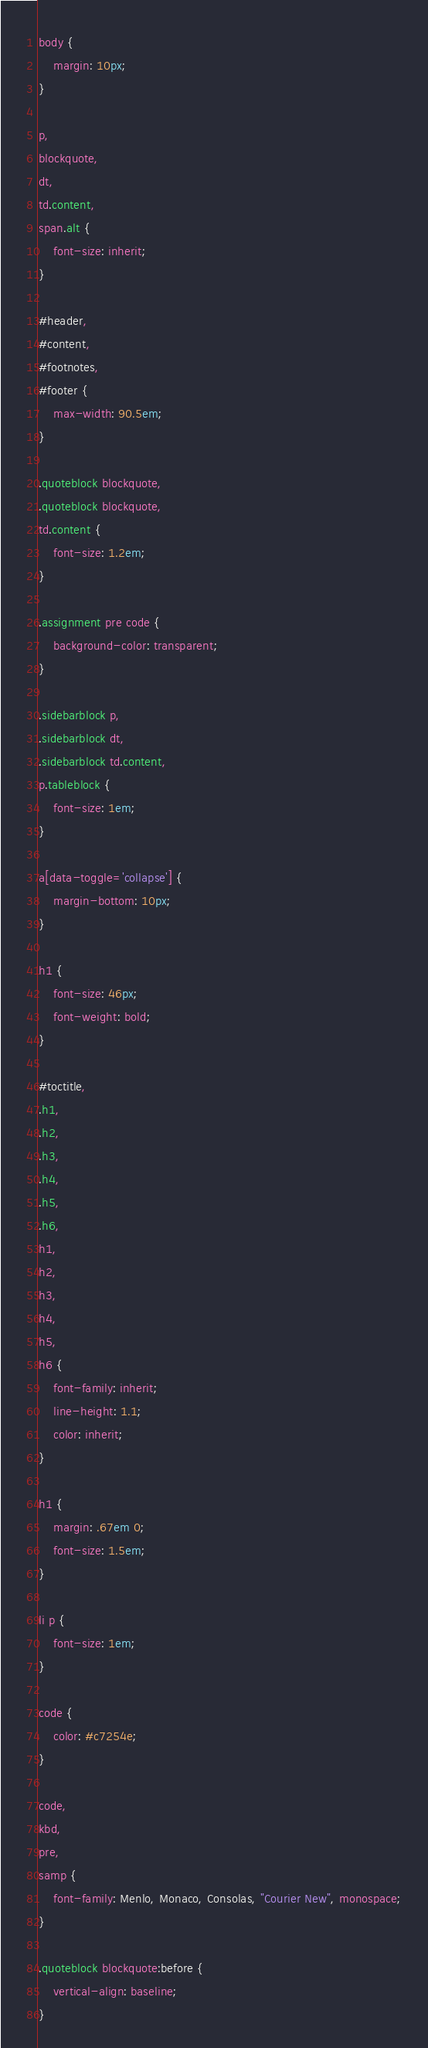<code> <loc_0><loc_0><loc_500><loc_500><_CSS_>body {
    margin: 10px;
}

p,
blockquote,
dt,
td.content,
span.alt {
    font-size: inherit;
}

#header,
#content,
#footnotes,
#footer {
    max-width: 90.5em;
}

.quoteblock blockquote,
.quoteblock blockquote,
td.content {
    font-size: 1.2em;
}

.assignment pre code {
    background-color: transparent;
}

.sidebarblock p,
.sidebarblock dt,
.sidebarblock td.content,
p.tableblock {
    font-size: 1em;
}

a[data-toggle='collapse'] {
    margin-bottom: 10px;
}

h1 {
    font-size: 46px;
    font-weight: bold;
}

#toctitle,
.h1,
.h2,
.h3,
.h4,
.h5,
.h6,
h1,
h2,
h3,
h4,
h5,
h6 {
    font-family: inherit;
    line-height: 1.1;
    color: inherit;
}

h1 {
    margin: .67em 0;
    font-size: 1.5em;
}

li p {
    font-size: 1em;
}

code {
    color: #c7254e;
}

code,
kbd,
pre,
samp {
    font-family: Menlo, Monaco, Consolas, "Courier New", monospace;
}

.quoteblock blockquote:before {
    vertical-align: baseline;
}</code> 